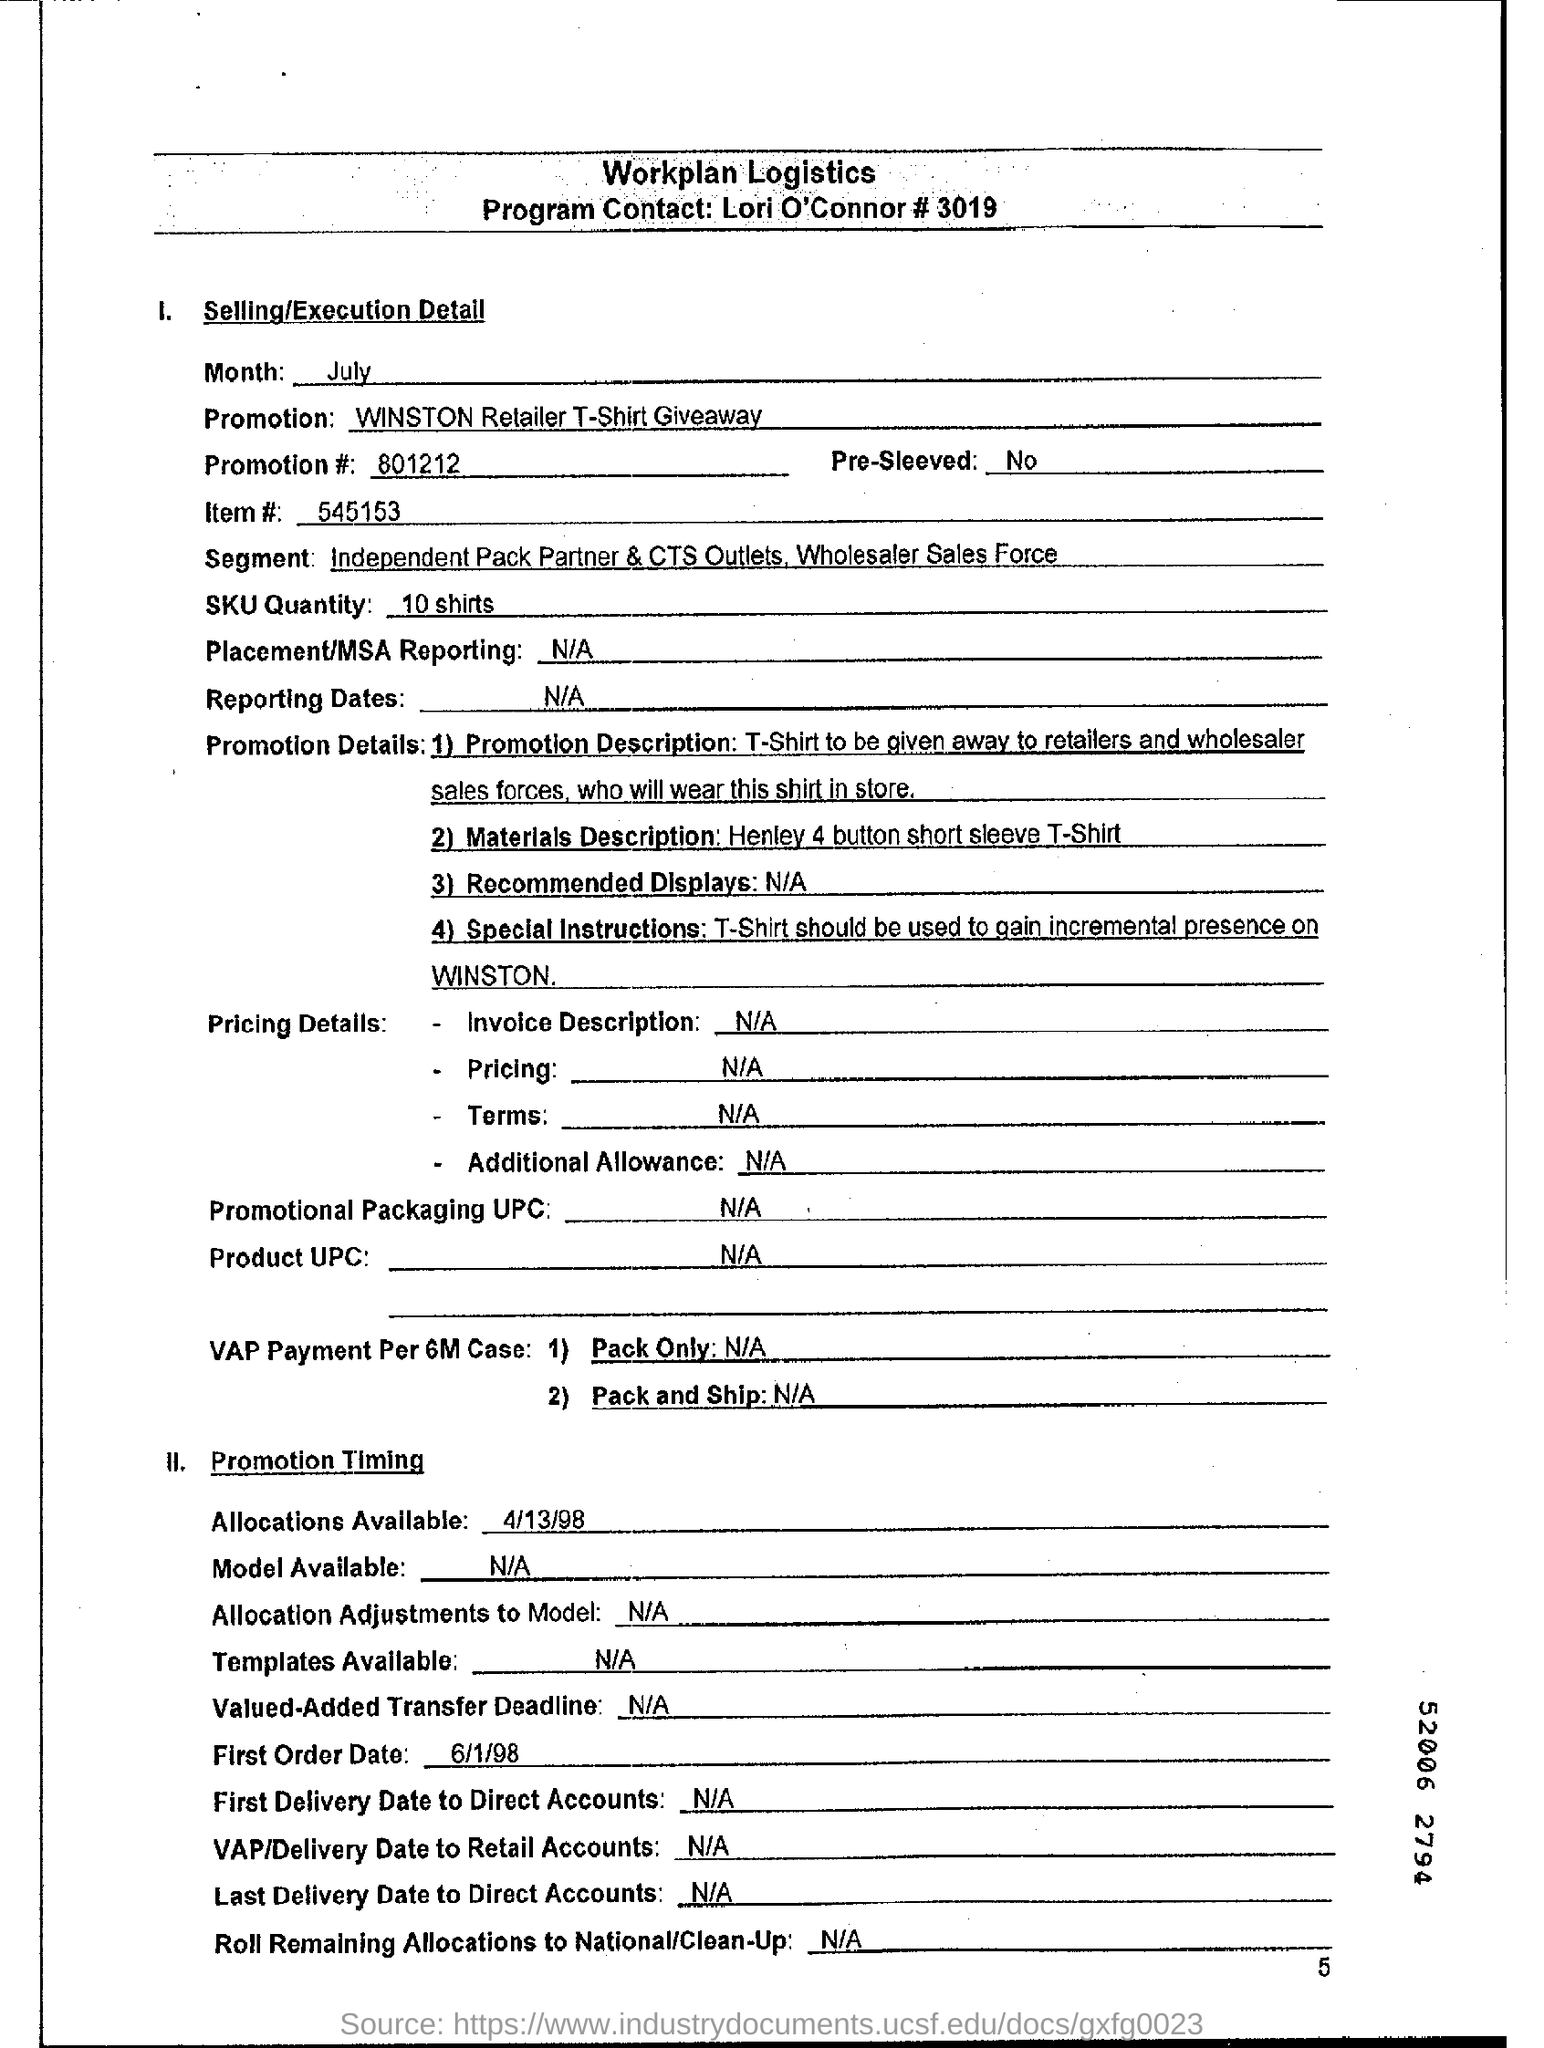Give some essential details in this illustration. There are four promotion details available. The allocation will be available on April 13, 1998. The first order date is June 1, 1998. 